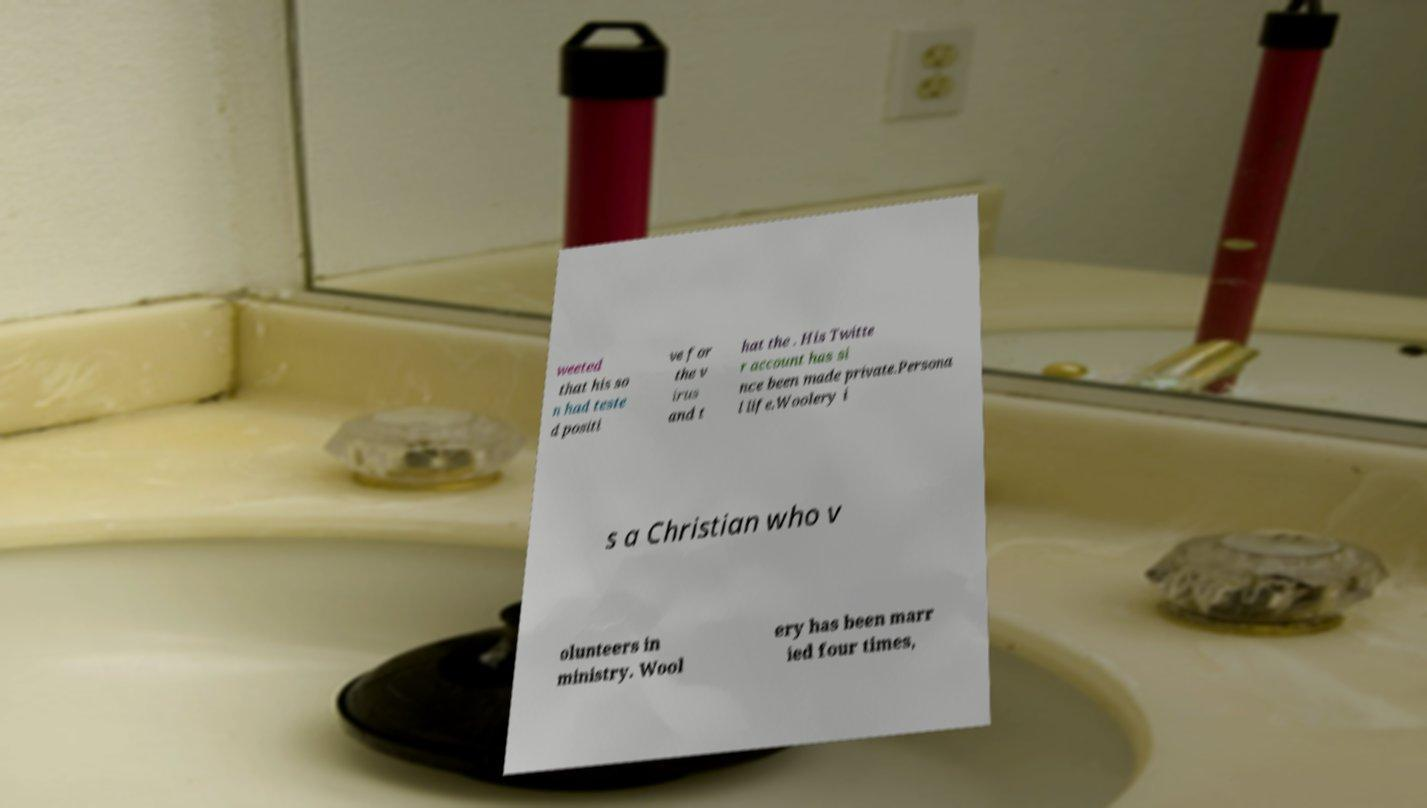Can you read and provide the text displayed in the image?This photo seems to have some interesting text. Can you extract and type it out for me? weeted that his so n had teste d positi ve for the v irus and t hat the . His Twitte r account has si nce been made private.Persona l life.Woolery i s a Christian who v olunteers in ministry. Wool ery has been marr ied four times, 